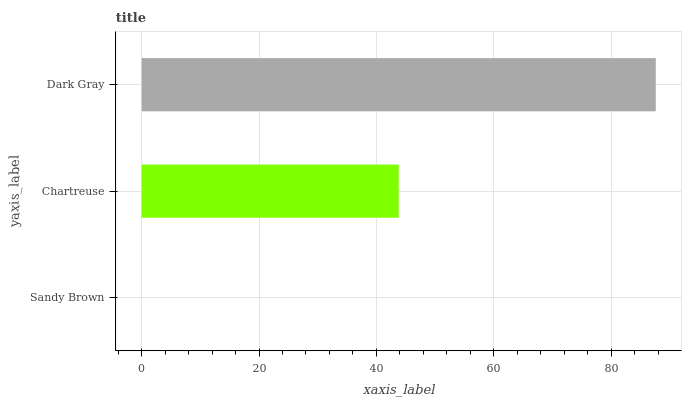Is Sandy Brown the minimum?
Answer yes or no. Yes. Is Dark Gray the maximum?
Answer yes or no. Yes. Is Chartreuse the minimum?
Answer yes or no. No. Is Chartreuse the maximum?
Answer yes or no. No. Is Chartreuse greater than Sandy Brown?
Answer yes or no. Yes. Is Sandy Brown less than Chartreuse?
Answer yes or no. Yes. Is Sandy Brown greater than Chartreuse?
Answer yes or no. No. Is Chartreuse less than Sandy Brown?
Answer yes or no. No. Is Chartreuse the high median?
Answer yes or no. Yes. Is Chartreuse the low median?
Answer yes or no. Yes. Is Dark Gray the high median?
Answer yes or no. No. Is Sandy Brown the low median?
Answer yes or no. No. 